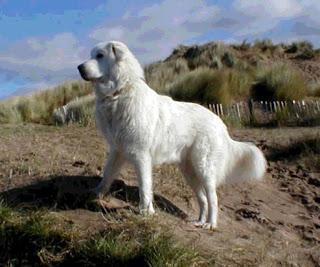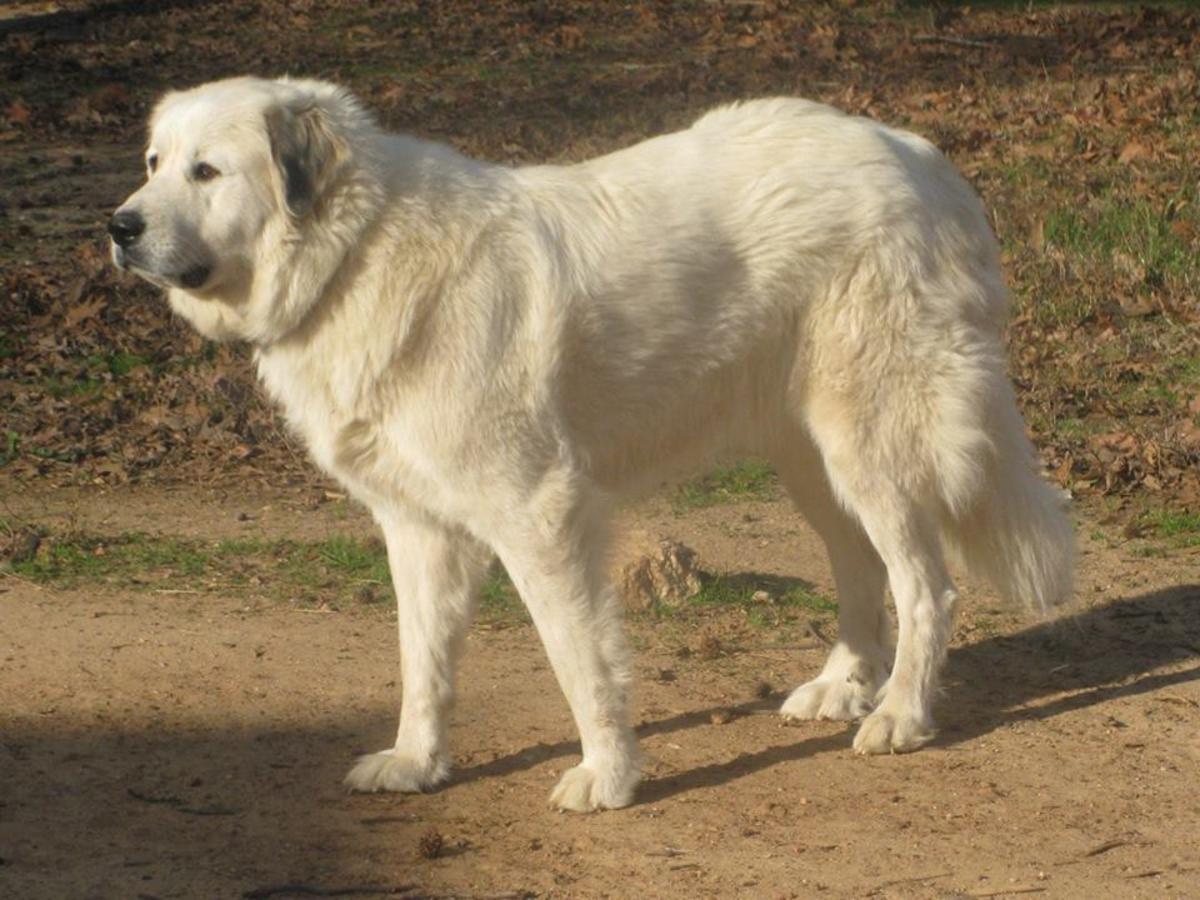The first image is the image on the left, the second image is the image on the right. Assess this claim about the two images: "Every image contains only one dog". Correct or not? Answer yes or no. Yes. The first image is the image on the left, the second image is the image on the right. Considering the images on both sides, is "There is a lone dog facing the camera in one image and a dog with at least one puppy in the other image." valid? Answer yes or no. No. 